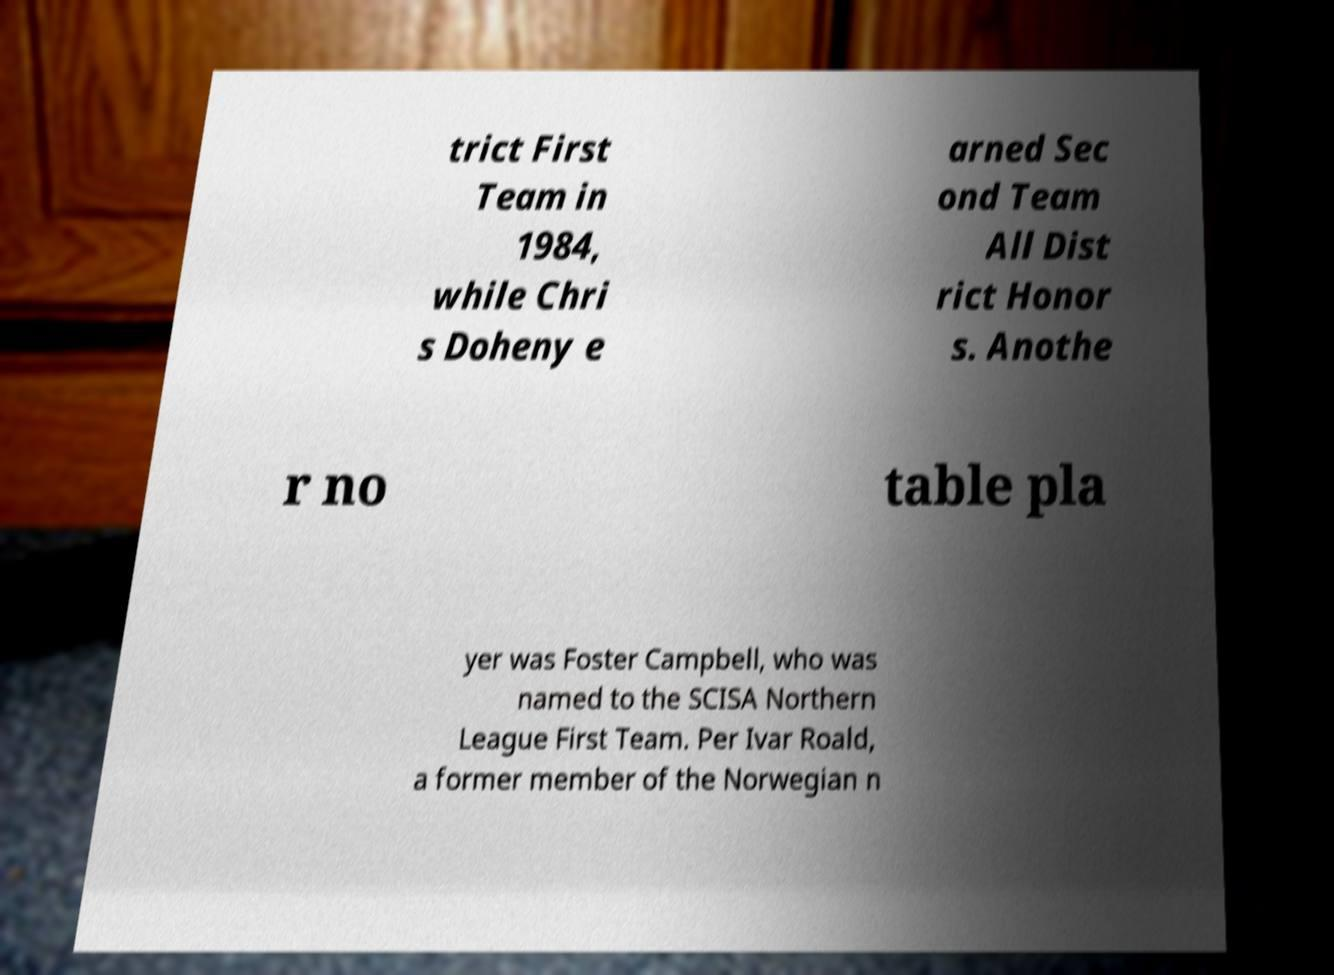There's text embedded in this image that I need extracted. Can you transcribe it verbatim? trict First Team in 1984, while Chri s Doheny e arned Sec ond Team All Dist rict Honor s. Anothe r no table pla yer was Foster Campbell, who was named to the SCISA Northern League First Team. Per Ivar Roald, a former member of the Norwegian n 